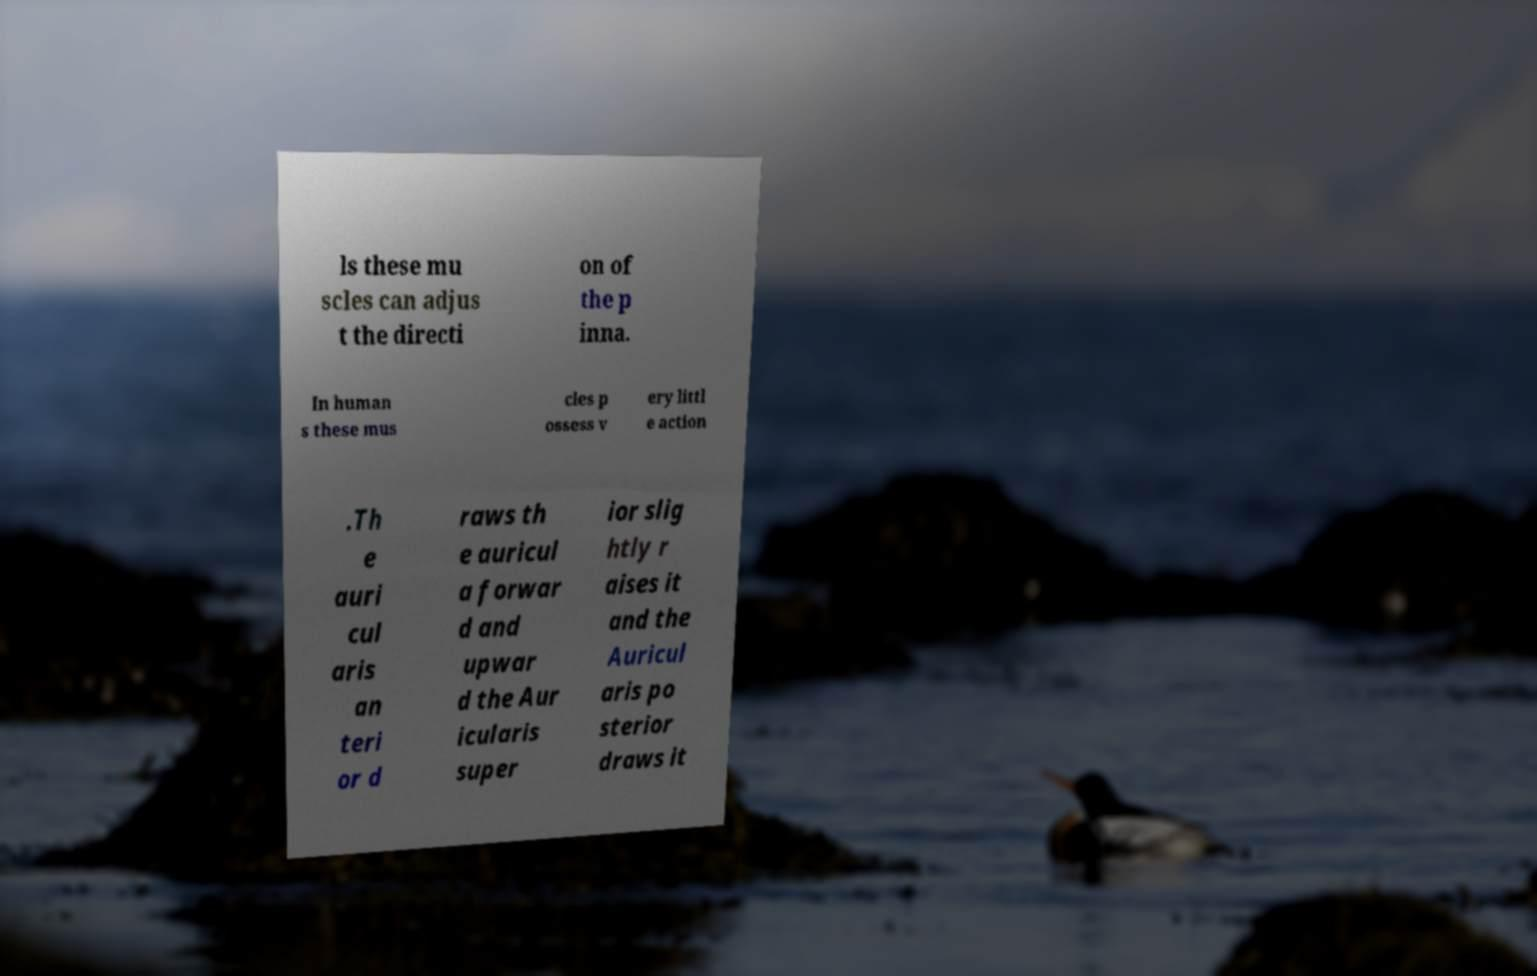Could you assist in decoding the text presented in this image and type it out clearly? ls these mu scles can adjus t the directi on of the p inna. In human s these mus cles p ossess v ery littl e action .Th e auri cul aris an teri or d raws th e auricul a forwar d and upwar d the Aur icularis super ior slig htly r aises it and the Auricul aris po sterior draws it 